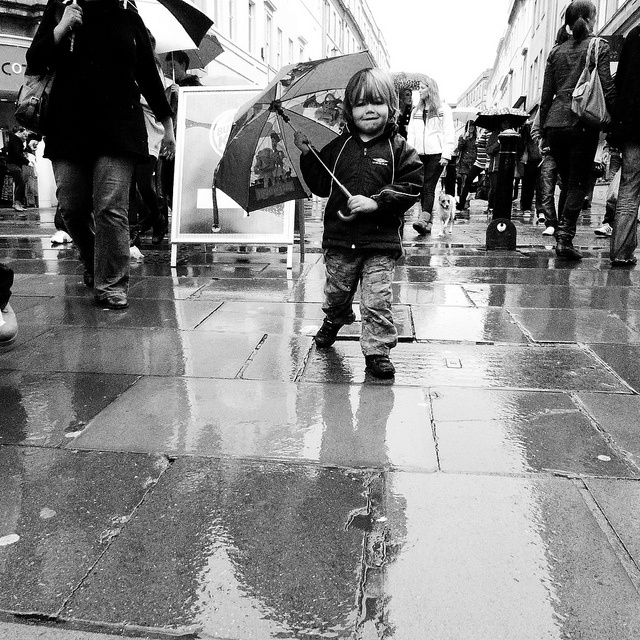Describe the objects in this image and their specific colors. I can see people in gray, black, darkgray, and lightgray tones, people in gray, black, darkgray, and lightgray tones, umbrella in gray, black, darkgray, and lightgray tones, people in gray, black, darkgray, and lightgray tones, and people in gray, black, darkgray, and lightgray tones in this image. 